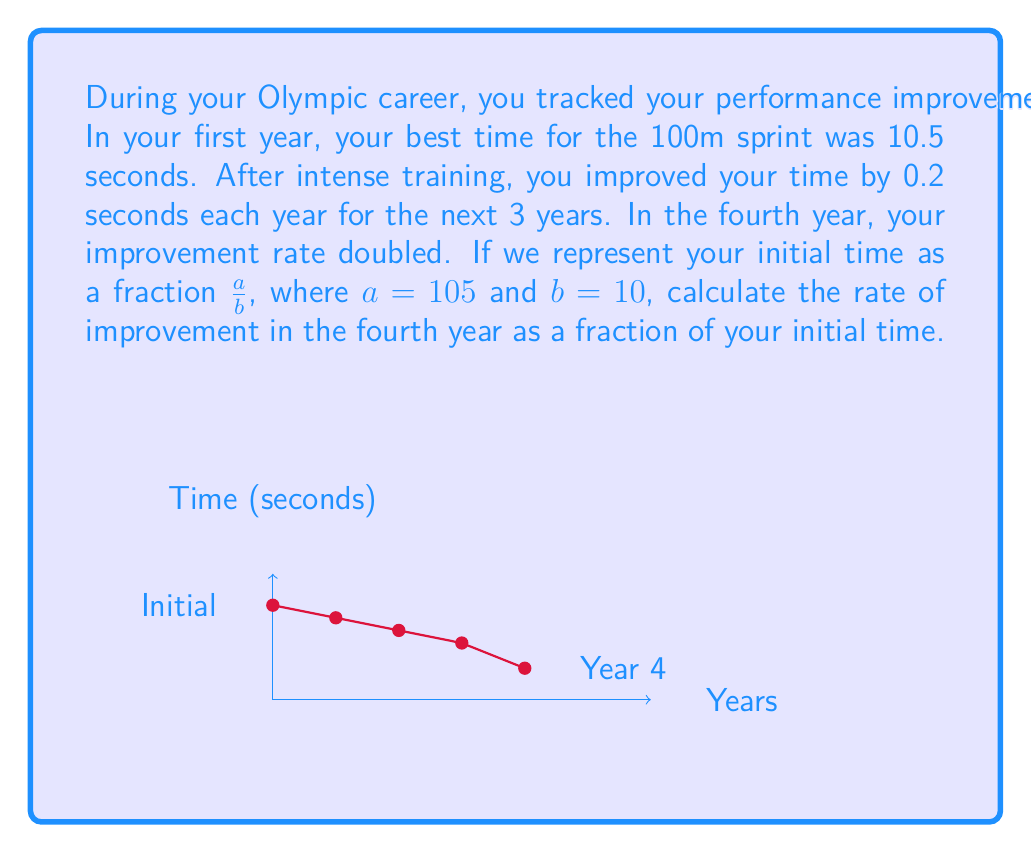Could you help me with this problem? Let's approach this step-by-step:

1) First, let's calculate your time after 3 years of improvement:
   Initial time: 10.5 seconds
   Improvement each year: 0.2 seconds
   Time after 3 years = $10.5 - (3 \times 0.2) = 9.9$ seconds

2) In the fourth year, the improvement rate doubled. So the improvement was:
   $0.2 \times 2 = 0.4$ seconds

3) Your time after the fourth year:
   $9.9 - 0.4 = 9.5$ seconds

4) Now, we need to express this improvement as a fraction of your initial time.
   Initial time: $\frac{a}{b} = \frac{105}{10} = 10.5$ seconds
   Improvement in fourth year: $0.4$ seconds

5) To express the improvement as a fraction of the initial time:
   $\frac{\text{Improvement}}{\text{Initial Time}} = \frac{0.4}{10.5} = \frac{4}{105}$

6) We can simplify this fraction:
   $\frac{4}{105} = \frac{4 \div 1}{105 \div 1} = \frac{4}{105}$

Therefore, the rate of improvement in the fourth year as a fraction of your initial time is $\frac{4}{105}$.
Answer: $\frac{4}{105}$ 